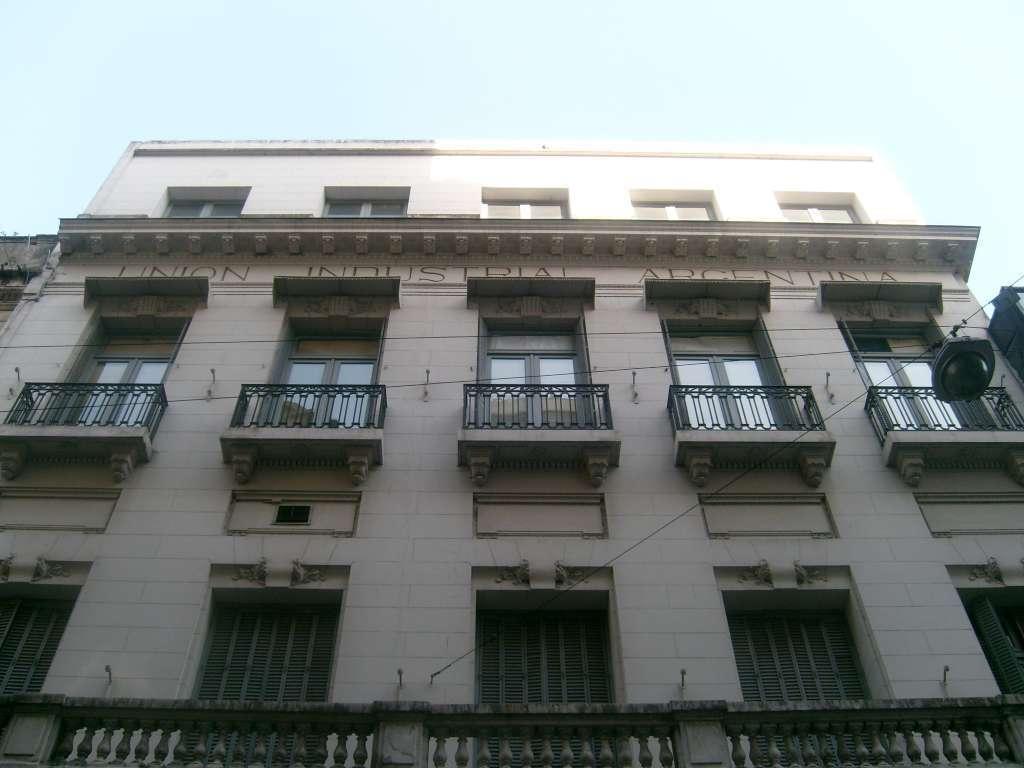Can you describe this image briefly? In the foreground of this image, there is a building and a lamp like an object to a cable. We can also see railings, windows to the building and at the top, there is the sky. 